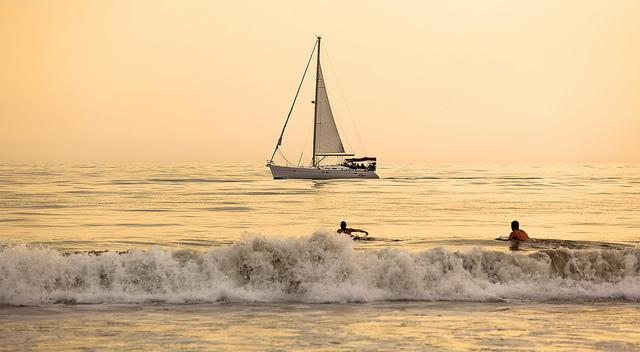How is this boat powered? wind 